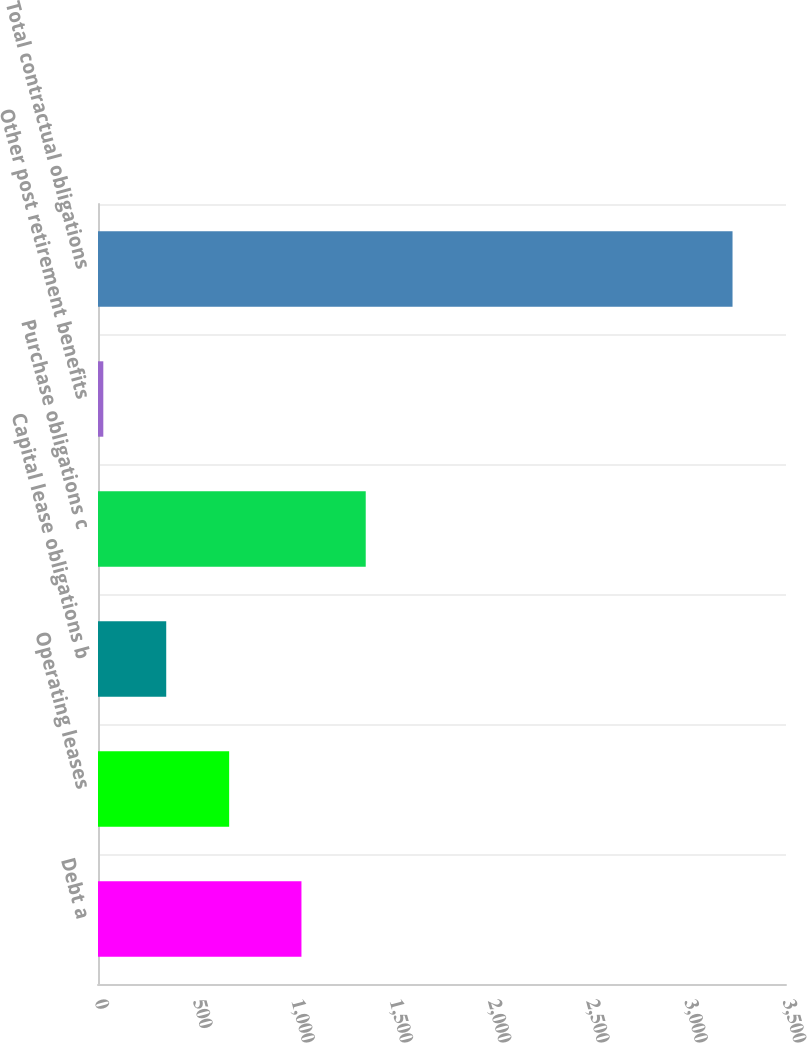Convert chart. <chart><loc_0><loc_0><loc_500><loc_500><bar_chart><fcel>Debt a<fcel>Operating leases<fcel>Capital lease obligations b<fcel>Purchase obligations c<fcel>Other post retirement benefits<fcel>Total contractual obligations<nl><fcel>1035<fcel>667.2<fcel>347.1<fcel>1362<fcel>27<fcel>3228<nl></chart> 